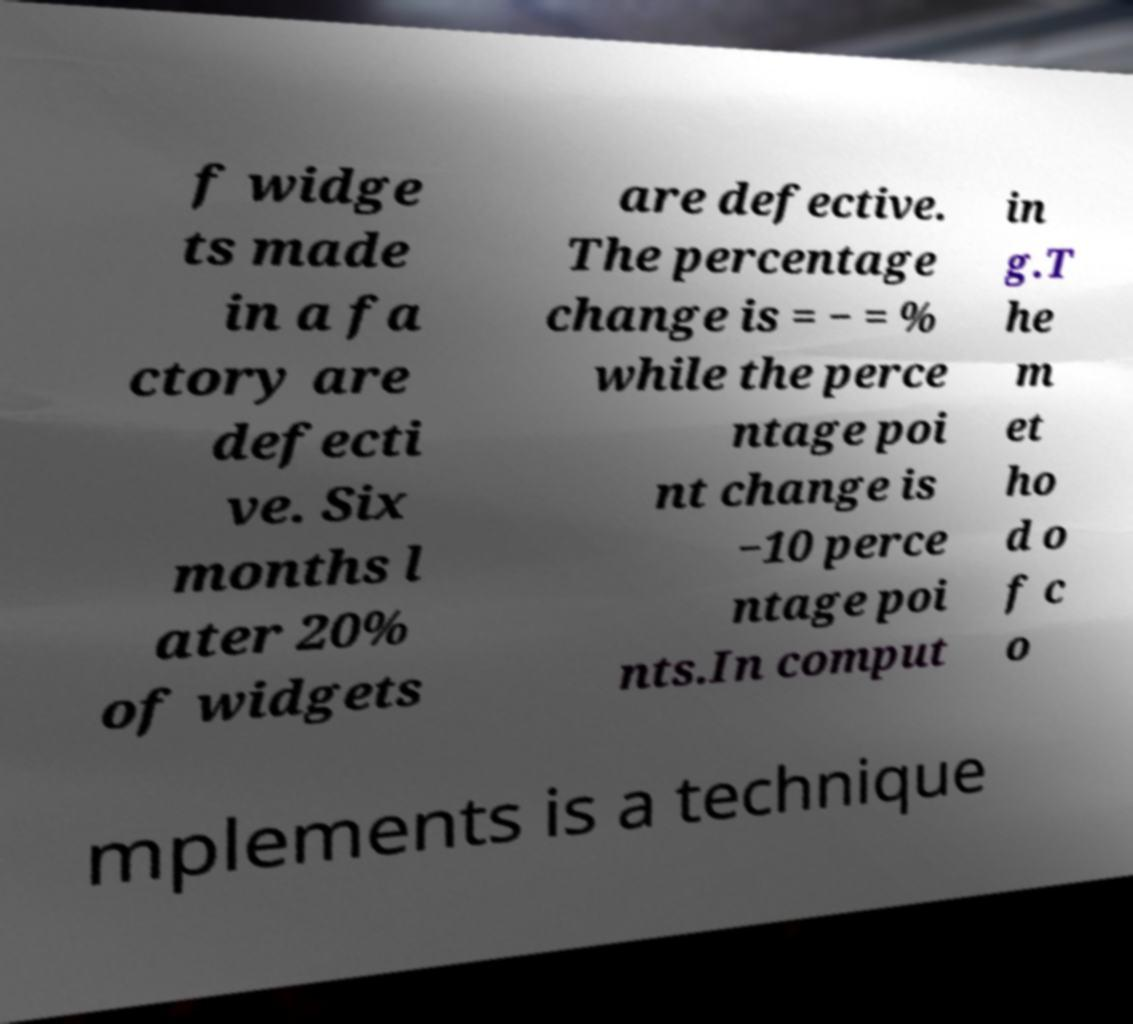Could you assist in decoding the text presented in this image and type it out clearly? f widge ts made in a fa ctory are defecti ve. Six months l ater 20% of widgets are defective. The percentage change is = − = % while the perce ntage poi nt change is −10 perce ntage poi nts.In comput in g.T he m et ho d o f c o mplements is a technique 